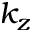<formula> <loc_0><loc_0><loc_500><loc_500>k _ { z }</formula> 